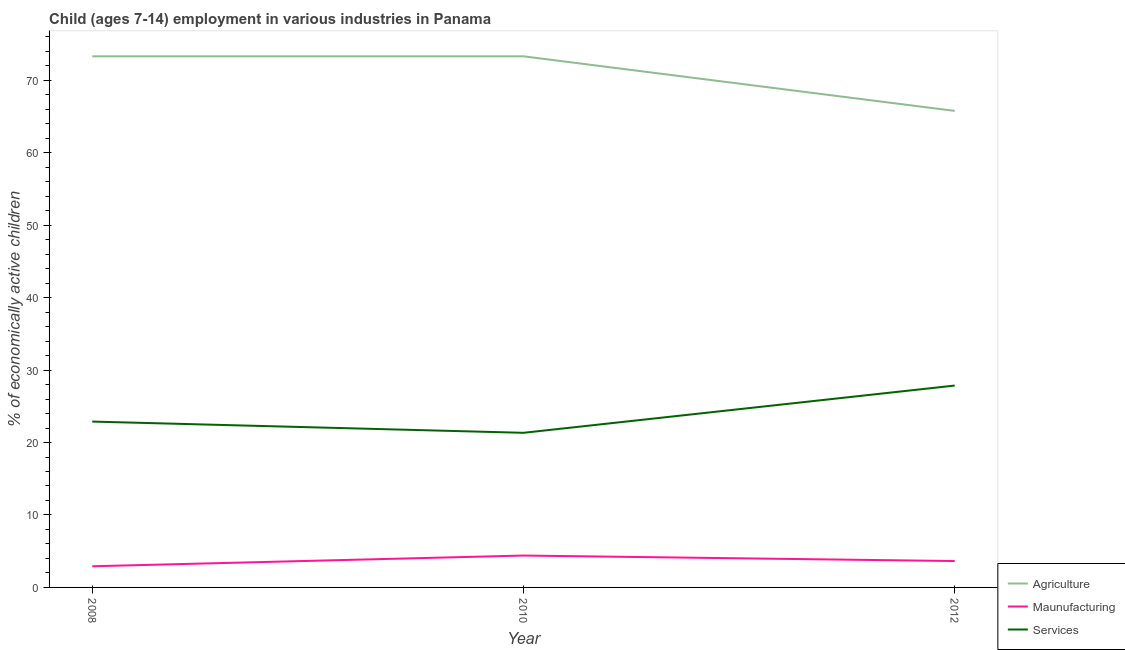Does the line corresponding to percentage of economically active children in services intersect with the line corresponding to percentage of economically active children in manufacturing?
Your response must be concise. No. What is the percentage of economically active children in services in 2012?
Your response must be concise. 27.86. Across all years, what is the maximum percentage of economically active children in services?
Your response must be concise. 27.86. Across all years, what is the minimum percentage of economically active children in agriculture?
Offer a terse response. 65.77. In which year was the percentage of economically active children in services maximum?
Your response must be concise. 2012. In which year was the percentage of economically active children in agriculture minimum?
Your answer should be very brief. 2012. What is the total percentage of economically active children in services in the graph?
Offer a very short reply. 72.09. What is the difference between the percentage of economically active children in agriculture in 2008 and that in 2012?
Ensure brevity in your answer.  7.53. What is the difference between the percentage of economically active children in services in 2008 and the percentage of economically active children in manufacturing in 2012?
Your answer should be compact. 19.25. What is the average percentage of economically active children in agriculture per year?
Make the answer very short. 70.79. In the year 2008, what is the difference between the percentage of economically active children in services and percentage of economically active children in manufacturing?
Offer a very short reply. 19.97. What is the ratio of the percentage of economically active children in manufacturing in 2008 to that in 2012?
Offer a terse response. 0.8. What is the difference between the highest and the second highest percentage of economically active children in manufacturing?
Your answer should be compact. 0.76. What is the difference between the highest and the lowest percentage of economically active children in services?
Ensure brevity in your answer.  6.52. In how many years, is the percentage of economically active children in agriculture greater than the average percentage of economically active children in agriculture taken over all years?
Provide a succinct answer. 2. Is the sum of the percentage of economically active children in services in 2008 and 2012 greater than the maximum percentage of economically active children in manufacturing across all years?
Give a very brief answer. Yes. Is it the case that in every year, the sum of the percentage of economically active children in agriculture and percentage of economically active children in manufacturing is greater than the percentage of economically active children in services?
Offer a very short reply. Yes. Is the percentage of economically active children in manufacturing strictly less than the percentage of economically active children in services over the years?
Offer a very short reply. Yes. How many lines are there?
Make the answer very short. 3. What is the difference between two consecutive major ticks on the Y-axis?
Your response must be concise. 10. Are the values on the major ticks of Y-axis written in scientific E-notation?
Your answer should be very brief. No. Does the graph contain any zero values?
Offer a very short reply. No. Where does the legend appear in the graph?
Your answer should be very brief. Bottom right. What is the title of the graph?
Make the answer very short. Child (ages 7-14) employment in various industries in Panama. Does "Travel services" appear as one of the legend labels in the graph?
Make the answer very short. No. What is the label or title of the Y-axis?
Provide a succinct answer. % of economically active children. What is the % of economically active children in Agriculture in 2008?
Provide a short and direct response. 73.3. What is the % of economically active children in Maunufacturing in 2008?
Provide a short and direct response. 2.92. What is the % of economically active children of Services in 2008?
Ensure brevity in your answer.  22.89. What is the % of economically active children of Agriculture in 2010?
Ensure brevity in your answer.  73.3. What is the % of economically active children in Services in 2010?
Your answer should be very brief. 21.34. What is the % of economically active children of Agriculture in 2012?
Offer a terse response. 65.77. What is the % of economically active children in Maunufacturing in 2012?
Offer a terse response. 3.64. What is the % of economically active children of Services in 2012?
Your answer should be compact. 27.86. Across all years, what is the maximum % of economically active children of Agriculture?
Provide a short and direct response. 73.3. Across all years, what is the maximum % of economically active children in Services?
Your answer should be very brief. 27.86. Across all years, what is the minimum % of economically active children in Agriculture?
Ensure brevity in your answer.  65.77. Across all years, what is the minimum % of economically active children in Maunufacturing?
Your answer should be very brief. 2.92. Across all years, what is the minimum % of economically active children in Services?
Offer a very short reply. 21.34. What is the total % of economically active children of Agriculture in the graph?
Ensure brevity in your answer.  212.37. What is the total % of economically active children in Maunufacturing in the graph?
Ensure brevity in your answer.  10.96. What is the total % of economically active children of Services in the graph?
Provide a short and direct response. 72.09. What is the difference between the % of economically active children in Maunufacturing in 2008 and that in 2010?
Your answer should be very brief. -1.48. What is the difference between the % of economically active children in Services in 2008 and that in 2010?
Offer a very short reply. 1.55. What is the difference between the % of economically active children in Agriculture in 2008 and that in 2012?
Your answer should be very brief. 7.53. What is the difference between the % of economically active children in Maunufacturing in 2008 and that in 2012?
Provide a short and direct response. -0.72. What is the difference between the % of economically active children in Services in 2008 and that in 2012?
Offer a terse response. -4.97. What is the difference between the % of economically active children in Agriculture in 2010 and that in 2012?
Provide a succinct answer. 7.53. What is the difference between the % of economically active children in Maunufacturing in 2010 and that in 2012?
Your answer should be very brief. 0.76. What is the difference between the % of economically active children of Services in 2010 and that in 2012?
Give a very brief answer. -6.52. What is the difference between the % of economically active children in Agriculture in 2008 and the % of economically active children in Maunufacturing in 2010?
Give a very brief answer. 68.9. What is the difference between the % of economically active children in Agriculture in 2008 and the % of economically active children in Services in 2010?
Provide a short and direct response. 51.96. What is the difference between the % of economically active children of Maunufacturing in 2008 and the % of economically active children of Services in 2010?
Make the answer very short. -18.42. What is the difference between the % of economically active children in Agriculture in 2008 and the % of economically active children in Maunufacturing in 2012?
Your response must be concise. 69.66. What is the difference between the % of economically active children of Agriculture in 2008 and the % of economically active children of Services in 2012?
Offer a terse response. 45.44. What is the difference between the % of economically active children of Maunufacturing in 2008 and the % of economically active children of Services in 2012?
Make the answer very short. -24.94. What is the difference between the % of economically active children of Agriculture in 2010 and the % of economically active children of Maunufacturing in 2012?
Provide a short and direct response. 69.66. What is the difference between the % of economically active children of Agriculture in 2010 and the % of economically active children of Services in 2012?
Your answer should be very brief. 45.44. What is the difference between the % of economically active children of Maunufacturing in 2010 and the % of economically active children of Services in 2012?
Provide a succinct answer. -23.46. What is the average % of economically active children in Agriculture per year?
Keep it short and to the point. 70.79. What is the average % of economically active children of Maunufacturing per year?
Your answer should be very brief. 3.65. What is the average % of economically active children of Services per year?
Provide a short and direct response. 24.03. In the year 2008, what is the difference between the % of economically active children of Agriculture and % of economically active children of Maunufacturing?
Offer a terse response. 70.38. In the year 2008, what is the difference between the % of economically active children in Agriculture and % of economically active children in Services?
Your answer should be very brief. 50.41. In the year 2008, what is the difference between the % of economically active children of Maunufacturing and % of economically active children of Services?
Give a very brief answer. -19.97. In the year 2010, what is the difference between the % of economically active children of Agriculture and % of economically active children of Maunufacturing?
Offer a terse response. 68.9. In the year 2010, what is the difference between the % of economically active children of Agriculture and % of economically active children of Services?
Provide a succinct answer. 51.96. In the year 2010, what is the difference between the % of economically active children in Maunufacturing and % of economically active children in Services?
Ensure brevity in your answer.  -16.94. In the year 2012, what is the difference between the % of economically active children of Agriculture and % of economically active children of Maunufacturing?
Make the answer very short. 62.13. In the year 2012, what is the difference between the % of economically active children in Agriculture and % of economically active children in Services?
Make the answer very short. 37.91. In the year 2012, what is the difference between the % of economically active children of Maunufacturing and % of economically active children of Services?
Provide a short and direct response. -24.22. What is the ratio of the % of economically active children of Maunufacturing in 2008 to that in 2010?
Give a very brief answer. 0.66. What is the ratio of the % of economically active children of Services in 2008 to that in 2010?
Offer a terse response. 1.07. What is the ratio of the % of economically active children in Agriculture in 2008 to that in 2012?
Offer a terse response. 1.11. What is the ratio of the % of economically active children of Maunufacturing in 2008 to that in 2012?
Provide a short and direct response. 0.8. What is the ratio of the % of economically active children of Services in 2008 to that in 2012?
Your answer should be very brief. 0.82. What is the ratio of the % of economically active children in Agriculture in 2010 to that in 2012?
Your answer should be very brief. 1.11. What is the ratio of the % of economically active children in Maunufacturing in 2010 to that in 2012?
Provide a succinct answer. 1.21. What is the ratio of the % of economically active children in Services in 2010 to that in 2012?
Your answer should be very brief. 0.77. What is the difference between the highest and the second highest % of economically active children of Maunufacturing?
Offer a very short reply. 0.76. What is the difference between the highest and the second highest % of economically active children of Services?
Ensure brevity in your answer.  4.97. What is the difference between the highest and the lowest % of economically active children of Agriculture?
Offer a terse response. 7.53. What is the difference between the highest and the lowest % of economically active children in Maunufacturing?
Make the answer very short. 1.48. What is the difference between the highest and the lowest % of economically active children in Services?
Make the answer very short. 6.52. 